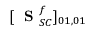<formula> <loc_0><loc_0><loc_500><loc_500>[ S _ { S C } ^ { f } ] _ { 0 1 , 0 1 }</formula> 